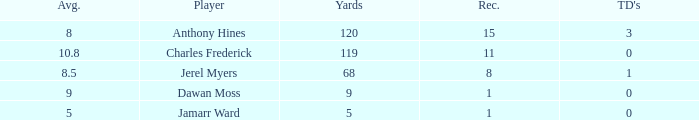What is the highest number of TDs when the Avg is larger than 8.5 and the Rec is less than 1? None. 